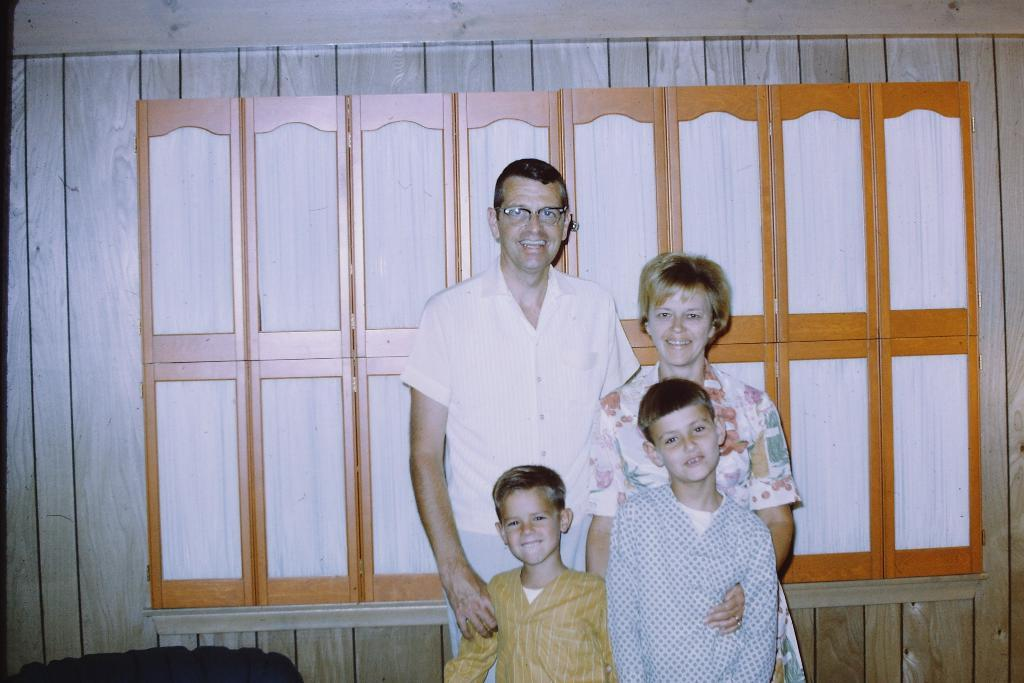How many people are visible in the background of the image? There are four people in the background of the image. What are the four people in the background doing? The four people are looking at someone. What type of bean is growing in the image? There is no bean present in the image. How does the toad interact with the land in the image? There is no toad present in the image, so it cannot interact with the land. 